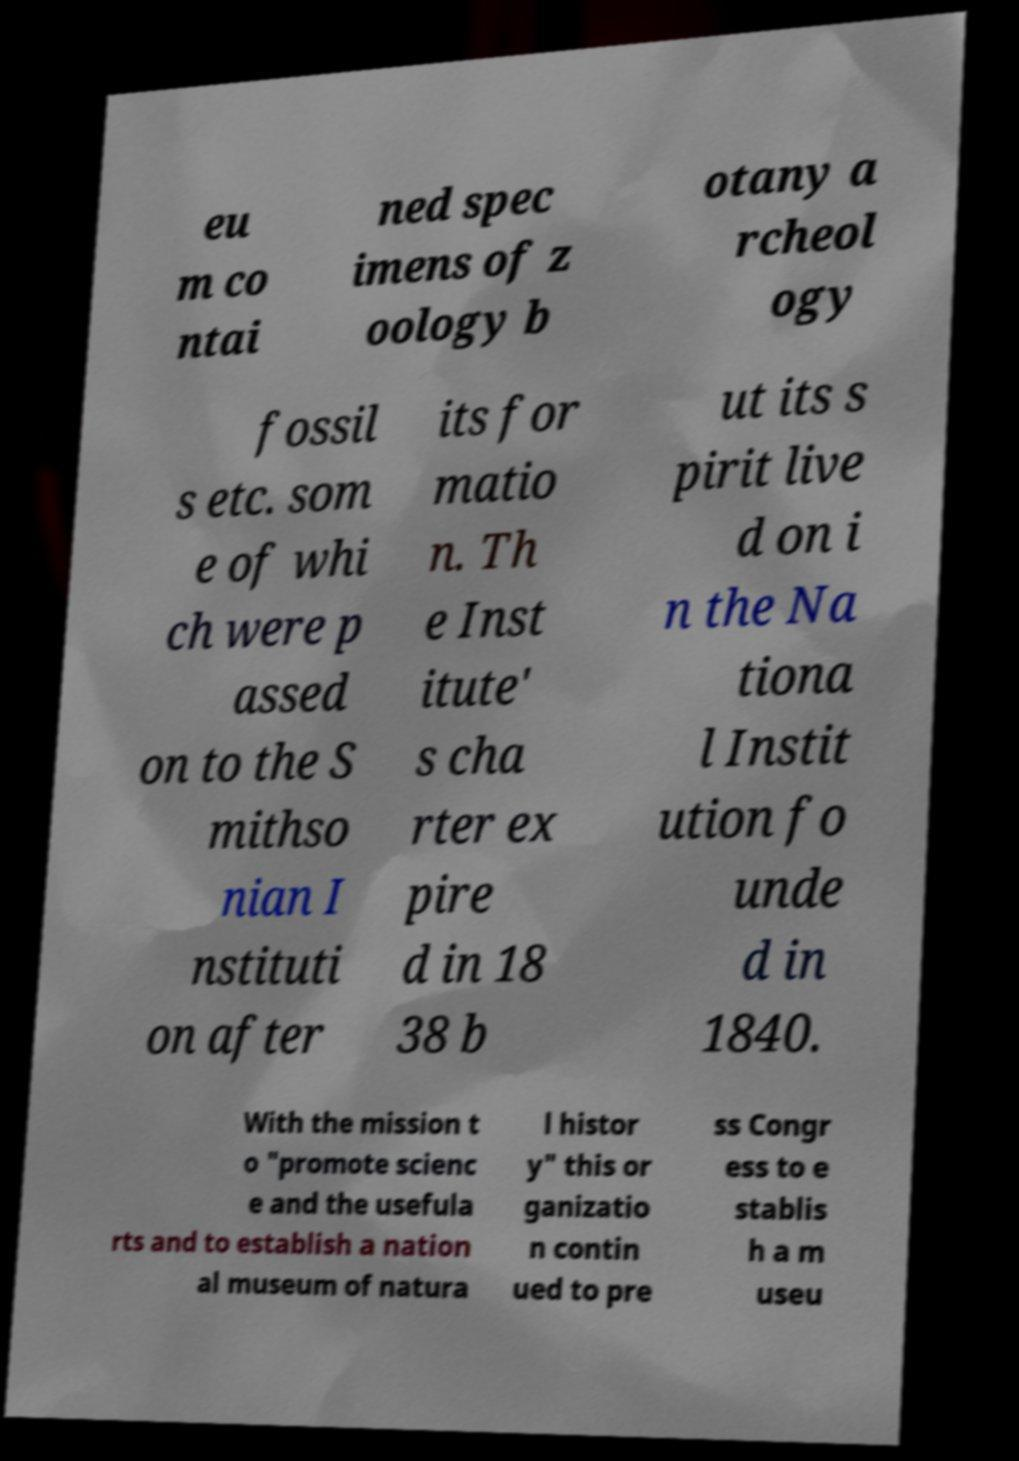I need the written content from this picture converted into text. Can you do that? eu m co ntai ned spec imens of z oology b otany a rcheol ogy fossil s etc. som e of whi ch were p assed on to the S mithso nian I nstituti on after its for matio n. Th e Inst itute' s cha rter ex pire d in 18 38 b ut its s pirit live d on i n the Na tiona l Instit ution fo unde d in 1840. With the mission t o "promote scienc e and the usefula rts and to establish a nation al museum of natura l histor y" this or ganizatio n contin ued to pre ss Congr ess to e stablis h a m useu 